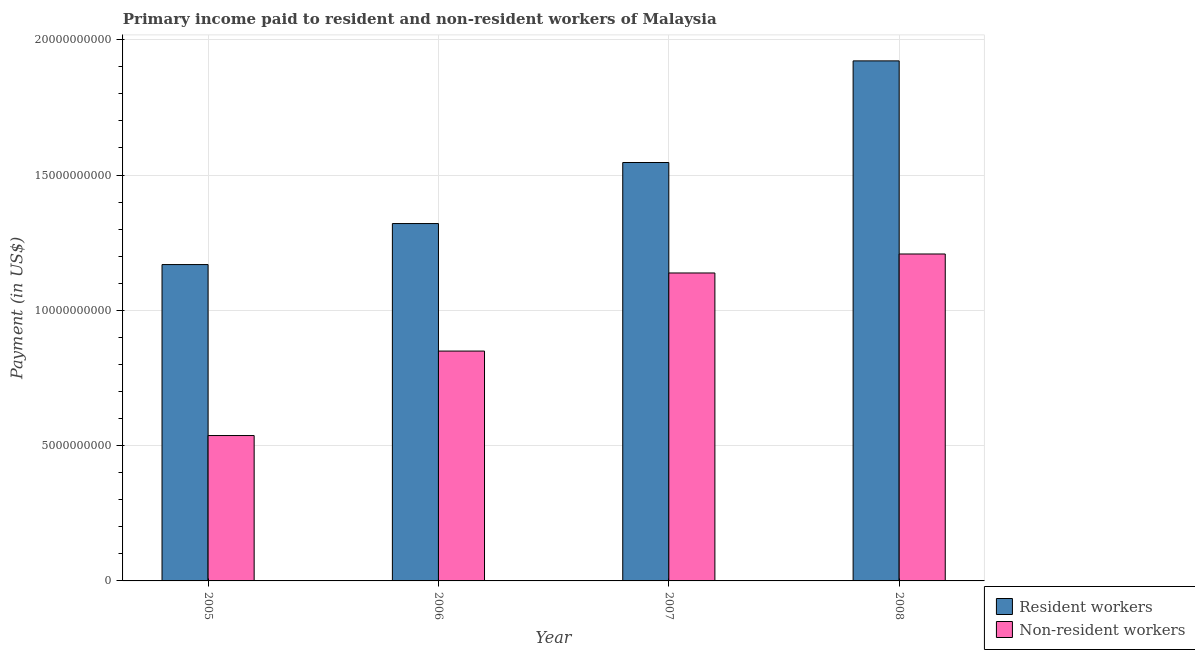How many bars are there on the 1st tick from the right?
Give a very brief answer. 2. What is the payment made to non-resident workers in 2006?
Your answer should be compact. 8.49e+09. Across all years, what is the maximum payment made to resident workers?
Provide a short and direct response. 1.92e+1. Across all years, what is the minimum payment made to non-resident workers?
Your answer should be very brief. 5.37e+09. In which year was the payment made to resident workers maximum?
Offer a very short reply. 2008. What is the total payment made to resident workers in the graph?
Give a very brief answer. 5.96e+1. What is the difference between the payment made to resident workers in 2005 and that in 2006?
Offer a very short reply. -1.52e+09. What is the difference between the payment made to non-resident workers in 2005 and the payment made to resident workers in 2006?
Offer a very short reply. -3.12e+09. What is the average payment made to non-resident workers per year?
Ensure brevity in your answer.  9.33e+09. What is the ratio of the payment made to non-resident workers in 2005 to that in 2008?
Offer a very short reply. 0.44. Is the payment made to resident workers in 2006 less than that in 2007?
Your answer should be compact. Yes. Is the difference between the payment made to non-resident workers in 2007 and 2008 greater than the difference between the payment made to resident workers in 2007 and 2008?
Make the answer very short. No. What is the difference between the highest and the second highest payment made to non-resident workers?
Provide a short and direct response. 7.01e+08. What is the difference between the highest and the lowest payment made to resident workers?
Ensure brevity in your answer.  7.53e+09. In how many years, is the payment made to non-resident workers greater than the average payment made to non-resident workers taken over all years?
Give a very brief answer. 2. Is the sum of the payment made to resident workers in 2005 and 2007 greater than the maximum payment made to non-resident workers across all years?
Make the answer very short. Yes. What does the 2nd bar from the left in 2006 represents?
Your answer should be compact. Non-resident workers. What does the 1st bar from the right in 2005 represents?
Offer a very short reply. Non-resident workers. How many bars are there?
Make the answer very short. 8. Are all the bars in the graph horizontal?
Ensure brevity in your answer.  No. How many years are there in the graph?
Provide a succinct answer. 4. Does the graph contain any zero values?
Provide a succinct answer. No. Where does the legend appear in the graph?
Offer a very short reply. Bottom right. How many legend labels are there?
Keep it short and to the point. 2. How are the legend labels stacked?
Give a very brief answer. Vertical. What is the title of the graph?
Your answer should be very brief. Primary income paid to resident and non-resident workers of Malaysia. What is the label or title of the Y-axis?
Offer a very short reply. Payment (in US$). What is the Payment (in US$) in Resident workers in 2005?
Your response must be concise. 1.17e+1. What is the Payment (in US$) of Non-resident workers in 2005?
Keep it short and to the point. 5.37e+09. What is the Payment (in US$) of Resident workers in 2006?
Make the answer very short. 1.32e+1. What is the Payment (in US$) in Non-resident workers in 2006?
Ensure brevity in your answer.  8.49e+09. What is the Payment (in US$) of Resident workers in 2007?
Offer a very short reply. 1.55e+1. What is the Payment (in US$) of Non-resident workers in 2007?
Give a very brief answer. 1.14e+1. What is the Payment (in US$) in Resident workers in 2008?
Offer a very short reply. 1.92e+1. What is the Payment (in US$) of Non-resident workers in 2008?
Provide a short and direct response. 1.21e+1. Across all years, what is the maximum Payment (in US$) of Resident workers?
Make the answer very short. 1.92e+1. Across all years, what is the maximum Payment (in US$) in Non-resident workers?
Your response must be concise. 1.21e+1. Across all years, what is the minimum Payment (in US$) in Resident workers?
Your answer should be compact. 1.17e+1. Across all years, what is the minimum Payment (in US$) in Non-resident workers?
Your answer should be very brief. 5.37e+09. What is the total Payment (in US$) of Resident workers in the graph?
Make the answer very short. 5.96e+1. What is the total Payment (in US$) of Non-resident workers in the graph?
Provide a succinct answer. 3.73e+1. What is the difference between the Payment (in US$) of Resident workers in 2005 and that in 2006?
Offer a terse response. -1.52e+09. What is the difference between the Payment (in US$) in Non-resident workers in 2005 and that in 2006?
Your response must be concise. -3.12e+09. What is the difference between the Payment (in US$) in Resident workers in 2005 and that in 2007?
Offer a terse response. -3.77e+09. What is the difference between the Payment (in US$) of Non-resident workers in 2005 and that in 2007?
Your answer should be very brief. -6.01e+09. What is the difference between the Payment (in US$) of Resident workers in 2005 and that in 2008?
Provide a succinct answer. -7.53e+09. What is the difference between the Payment (in US$) in Non-resident workers in 2005 and that in 2008?
Your answer should be compact. -6.71e+09. What is the difference between the Payment (in US$) of Resident workers in 2006 and that in 2007?
Keep it short and to the point. -2.26e+09. What is the difference between the Payment (in US$) of Non-resident workers in 2006 and that in 2007?
Your answer should be very brief. -2.89e+09. What is the difference between the Payment (in US$) in Resident workers in 2006 and that in 2008?
Offer a terse response. -6.01e+09. What is the difference between the Payment (in US$) of Non-resident workers in 2006 and that in 2008?
Provide a succinct answer. -3.59e+09. What is the difference between the Payment (in US$) of Resident workers in 2007 and that in 2008?
Your response must be concise. -3.76e+09. What is the difference between the Payment (in US$) in Non-resident workers in 2007 and that in 2008?
Offer a terse response. -7.01e+08. What is the difference between the Payment (in US$) in Resident workers in 2005 and the Payment (in US$) in Non-resident workers in 2006?
Your answer should be compact. 3.20e+09. What is the difference between the Payment (in US$) of Resident workers in 2005 and the Payment (in US$) of Non-resident workers in 2007?
Provide a succinct answer. 3.11e+08. What is the difference between the Payment (in US$) of Resident workers in 2005 and the Payment (in US$) of Non-resident workers in 2008?
Offer a very short reply. -3.90e+08. What is the difference between the Payment (in US$) in Resident workers in 2006 and the Payment (in US$) in Non-resident workers in 2007?
Offer a terse response. 1.83e+09. What is the difference between the Payment (in US$) of Resident workers in 2006 and the Payment (in US$) of Non-resident workers in 2008?
Your answer should be very brief. 1.12e+09. What is the difference between the Payment (in US$) in Resident workers in 2007 and the Payment (in US$) in Non-resident workers in 2008?
Keep it short and to the point. 3.38e+09. What is the average Payment (in US$) of Resident workers per year?
Keep it short and to the point. 1.49e+1. What is the average Payment (in US$) in Non-resident workers per year?
Keep it short and to the point. 9.33e+09. In the year 2005, what is the difference between the Payment (in US$) of Resident workers and Payment (in US$) of Non-resident workers?
Ensure brevity in your answer.  6.32e+09. In the year 2006, what is the difference between the Payment (in US$) in Resident workers and Payment (in US$) in Non-resident workers?
Your response must be concise. 4.71e+09. In the year 2007, what is the difference between the Payment (in US$) in Resident workers and Payment (in US$) in Non-resident workers?
Provide a succinct answer. 4.08e+09. In the year 2008, what is the difference between the Payment (in US$) of Resident workers and Payment (in US$) of Non-resident workers?
Provide a succinct answer. 7.14e+09. What is the ratio of the Payment (in US$) in Resident workers in 2005 to that in 2006?
Keep it short and to the point. 0.89. What is the ratio of the Payment (in US$) of Non-resident workers in 2005 to that in 2006?
Keep it short and to the point. 0.63. What is the ratio of the Payment (in US$) of Resident workers in 2005 to that in 2007?
Keep it short and to the point. 0.76. What is the ratio of the Payment (in US$) of Non-resident workers in 2005 to that in 2007?
Keep it short and to the point. 0.47. What is the ratio of the Payment (in US$) in Resident workers in 2005 to that in 2008?
Offer a terse response. 0.61. What is the ratio of the Payment (in US$) in Non-resident workers in 2005 to that in 2008?
Offer a very short reply. 0.44. What is the ratio of the Payment (in US$) of Resident workers in 2006 to that in 2007?
Keep it short and to the point. 0.85. What is the ratio of the Payment (in US$) of Non-resident workers in 2006 to that in 2007?
Your answer should be compact. 0.75. What is the ratio of the Payment (in US$) of Resident workers in 2006 to that in 2008?
Keep it short and to the point. 0.69. What is the ratio of the Payment (in US$) of Non-resident workers in 2006 to that in 2008?
Your response must be concise. 0.7. What is the ratio of the Payment (in US$) of Resident workers in 2007 to that in 2008?
Offer a terse response. 0.8. What is the ratio of the Payment (in US$) in Non-resident workers in 2007 to that in 2008?
Your answer should be compact. 0.94. What is the difference between the highest and the second highest Payment (in US$) of Resident workers?
Keep it short and to the point. 3.76e+09. What is the difference between the highest and the second highest Payment (in US$) of Non-resident workers?
Offer a terse response. 7.01e+08. What is the difference between the highest and the lowest Payment (in US$) of Resident workers?
Make the answer very short. 7.53e+09. What is the difference between the highest and the lowest Payment (in US$) of Non-resident workers?
Provide a short and direct response. 6.71e+09. 